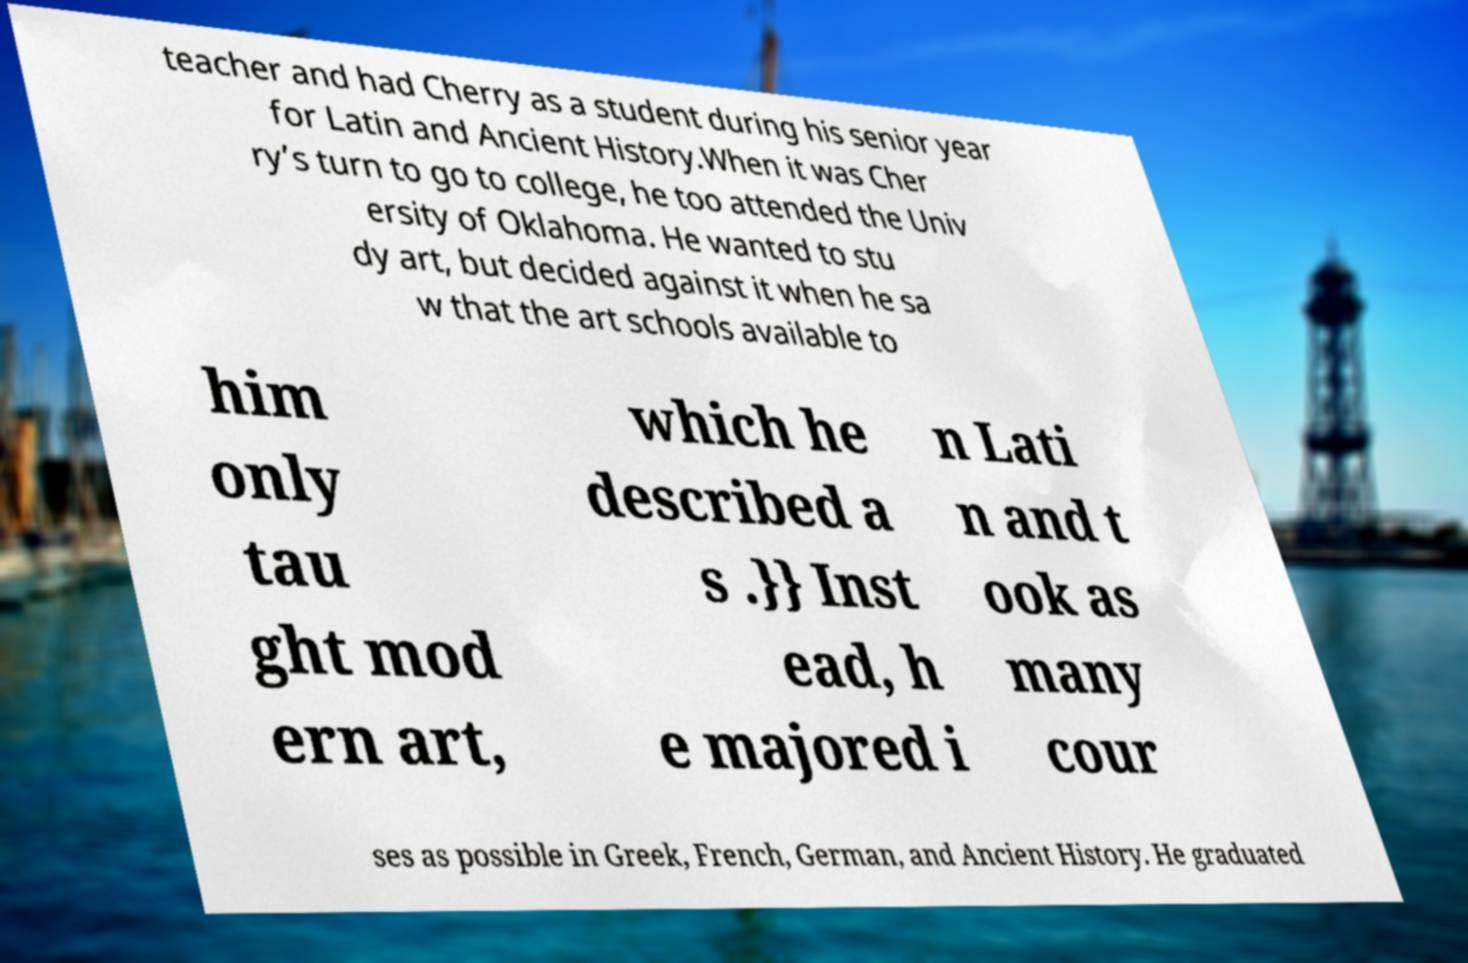Please read and relay the text visible in this image. What does it say? teacher and had Cherry as a student during his senior year for Latin and Ancient History.When it was Cher ry’s turn to go to college, he too attended the Univ ersity of Oklahoma. He wanted to stu dy art, but decided against it when he sa w that the art schools available to him only tau ght mod ern art, which he described a s .}} Inst ead, h e majored i n Lati n and t ook as many cour ses as possible in Greek, French, German, and Ancient History. He graduated 